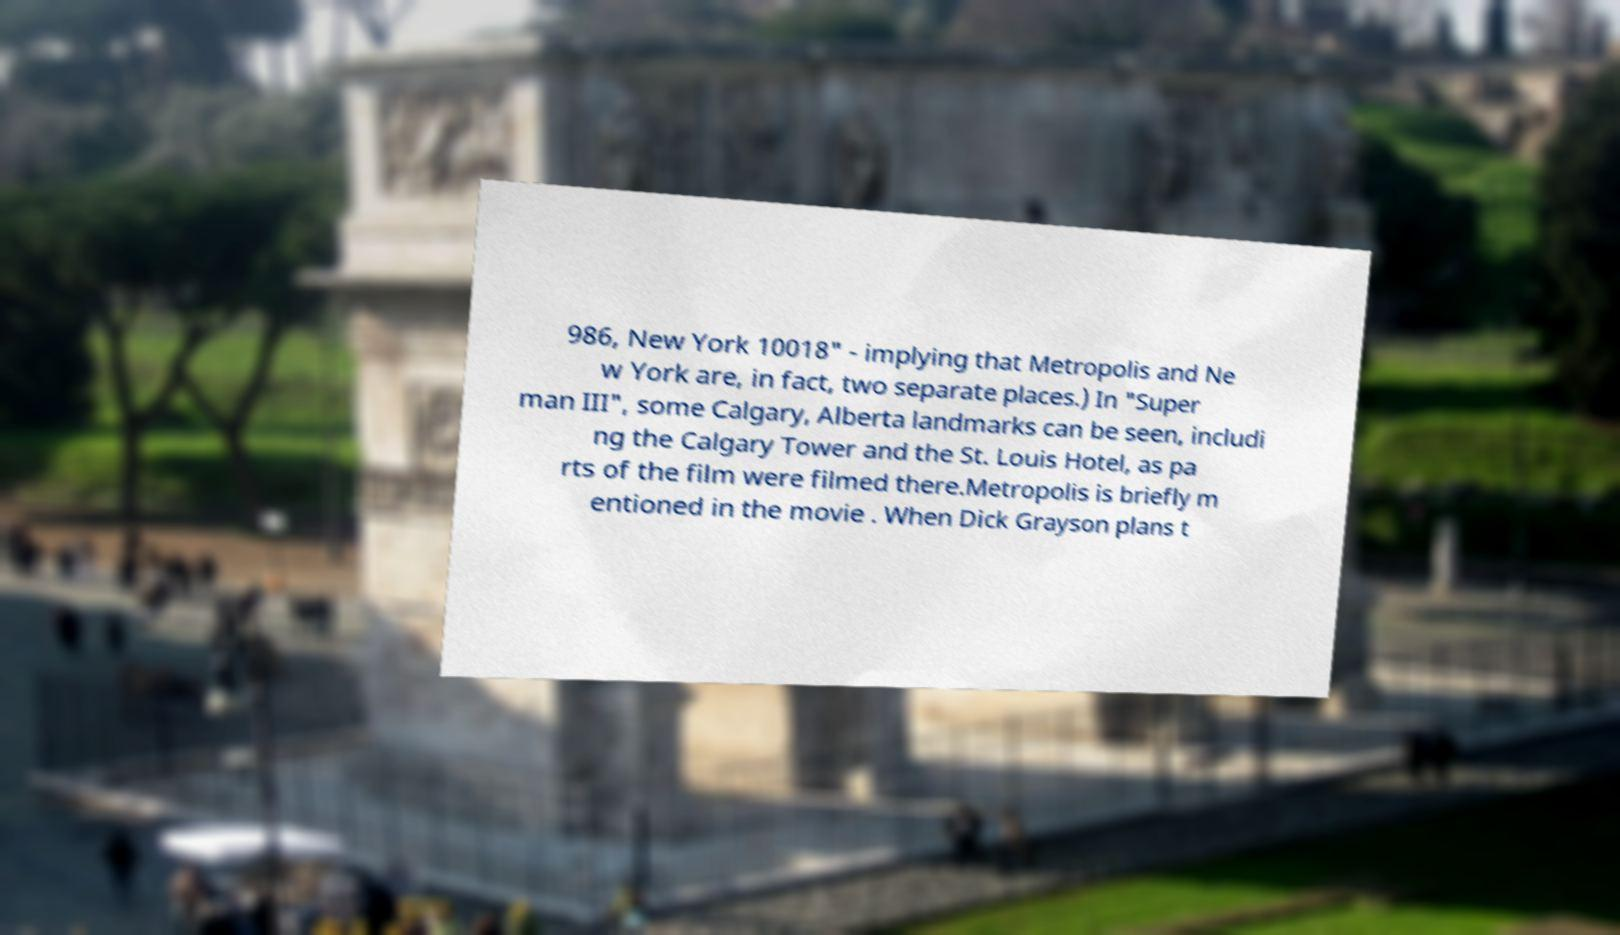For documentation purposes, I need the text within this image transcribed. Could you provide that? 986, New York 10018" - implying that Metropolis and Ne w York are, in fact, two separate places.) In "Super man III", some Calgary, Alberta landmarks can be seen, includi ng the Calgary Tower and the St. Louis Hotel, as pa rts of the film were filmed there.Metropolis is briefly m entioned in the movie . When Dick Grayson plans t 